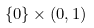Convert formula to latex. <formula><loc_0><loc_0><loc_500><loc_500>\{ 0 \} \times ( 0 , 1 )</formula> 